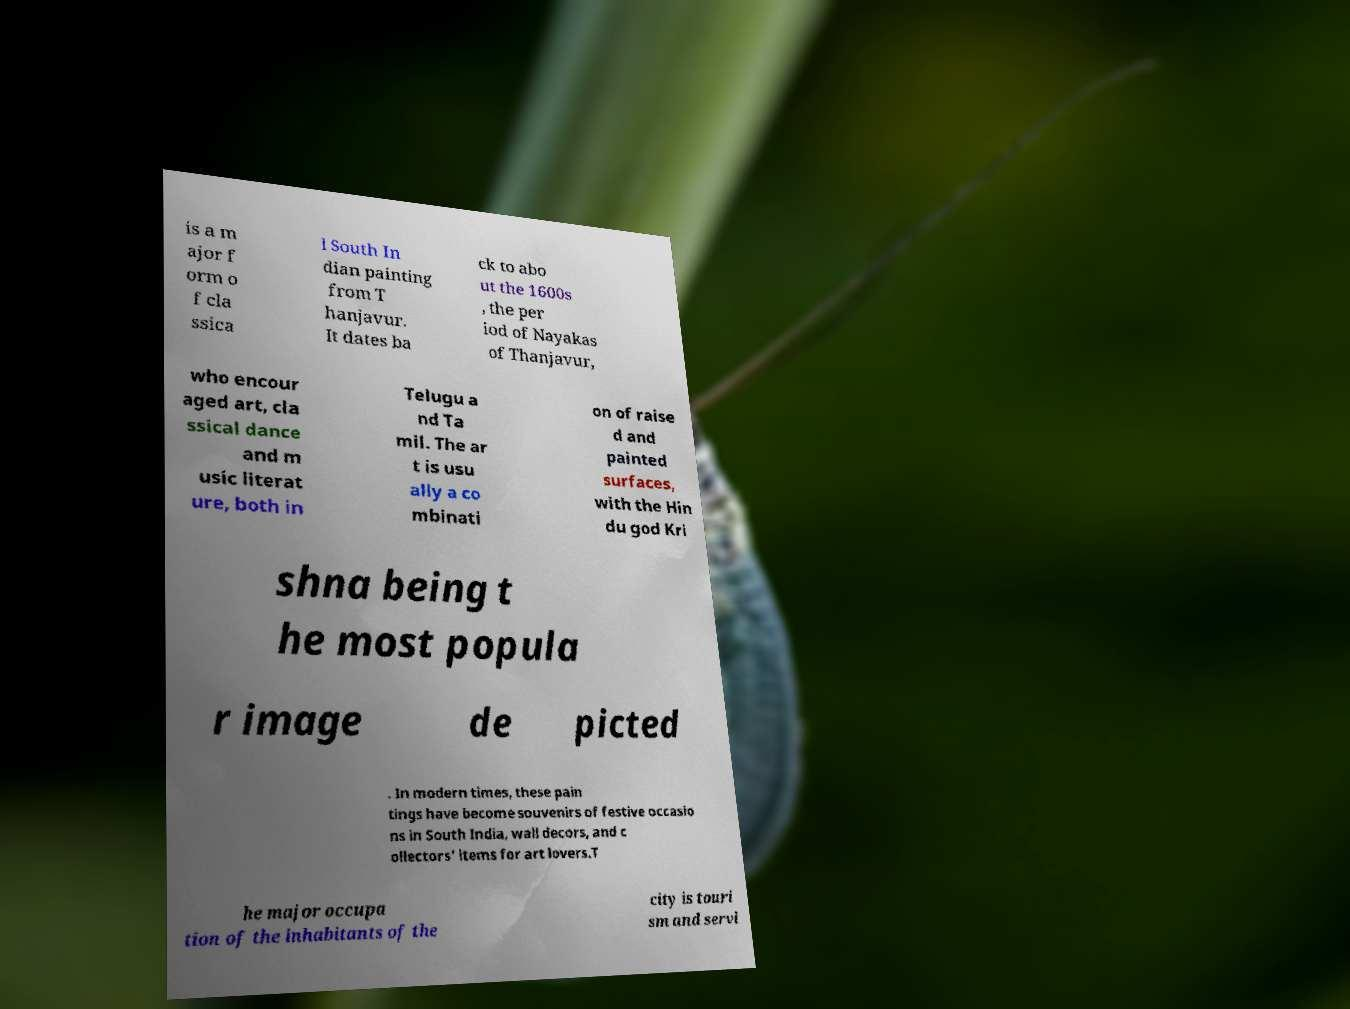Could you assist in decoding the text presented in this image and type it out clearly? is a m ajor f orm o f cla ssica l South In dian painting from T hanjavur. It dates ba ck to abo ut the 1600s , the per iod of Nayakas of Thanjavur, who encour aged art, cla ssical dance and m usic literat ure, both in Telugu a nd Ta mil. The ar t is usu ally a co mbinati on of raise d and painted surfaces, with the Hin du god Kri shna being t he most popula r image de picted . In modern times, these pain tings have become souvenirs of festive occasio ns in South India, wall decors, and c ollectors' items for art lovers.T he major occupa tion of the inhabitants of the city is touri sm and servi 